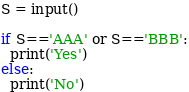Convert code to text. <code><loc_0><loc_0><loc_500><loc_500><_Python_>S = input()

if S=='AAA' or S=='BBB':
  print('Yes')
else:
  print('No')</code> 